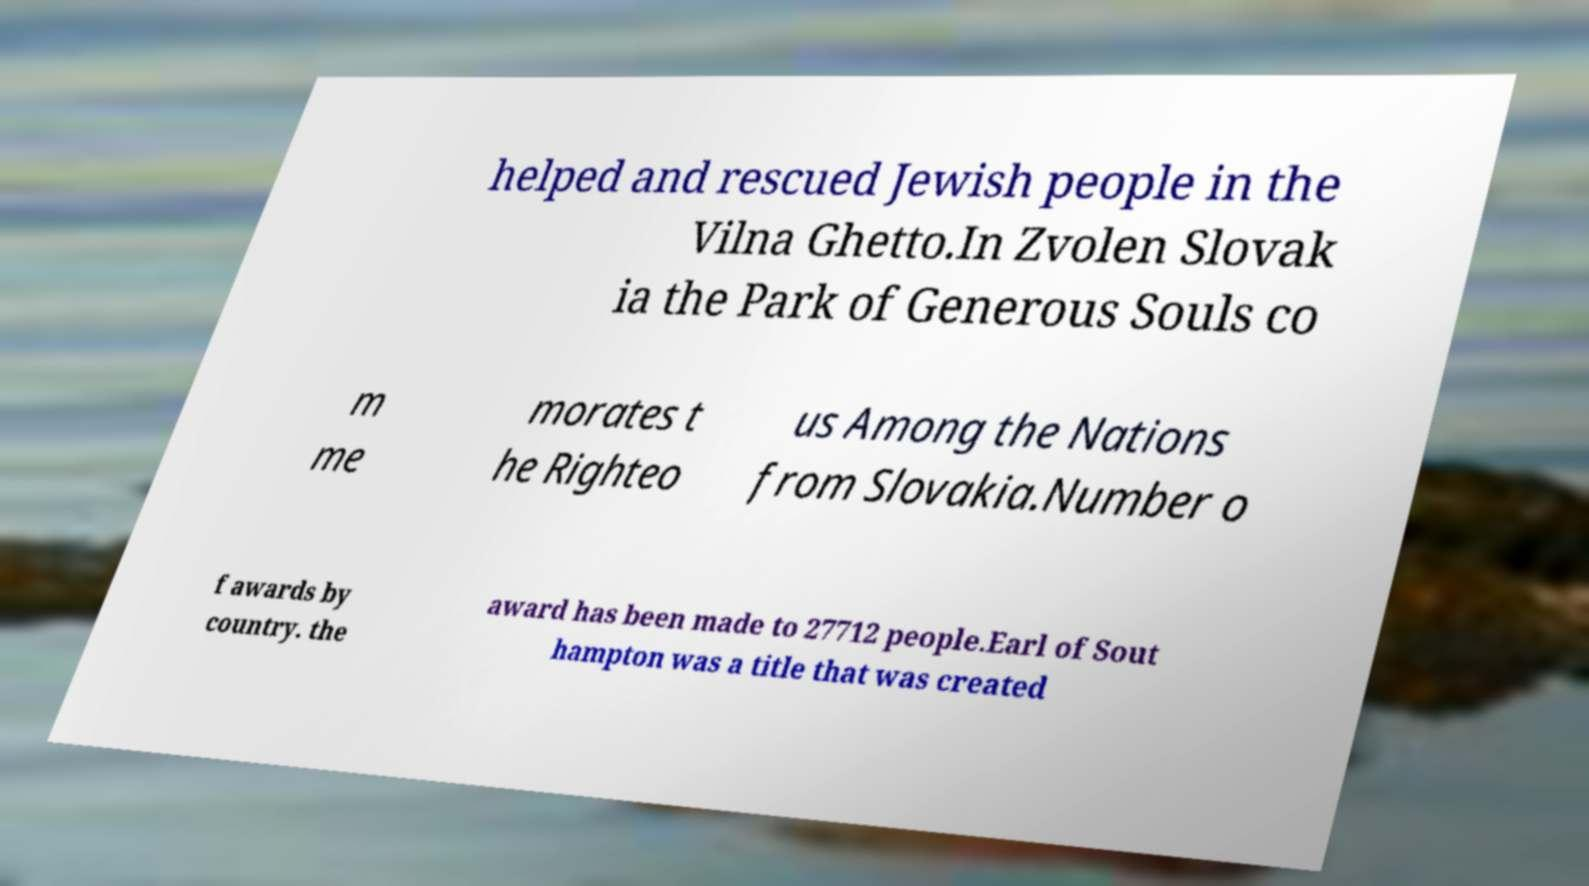For documentation purposes, I need the text within this image transcribed. Could you provide that? helped and rescued Jewish people in the Vilna Ghetto.In Zvolen Slovak ia the Park of Generous Souls co m me morates t he Righteo us Among the Nations from Slovakia.Number o f awards by country. the award has been made to 27712 people.Earl of Sout hampton was a title that was created 